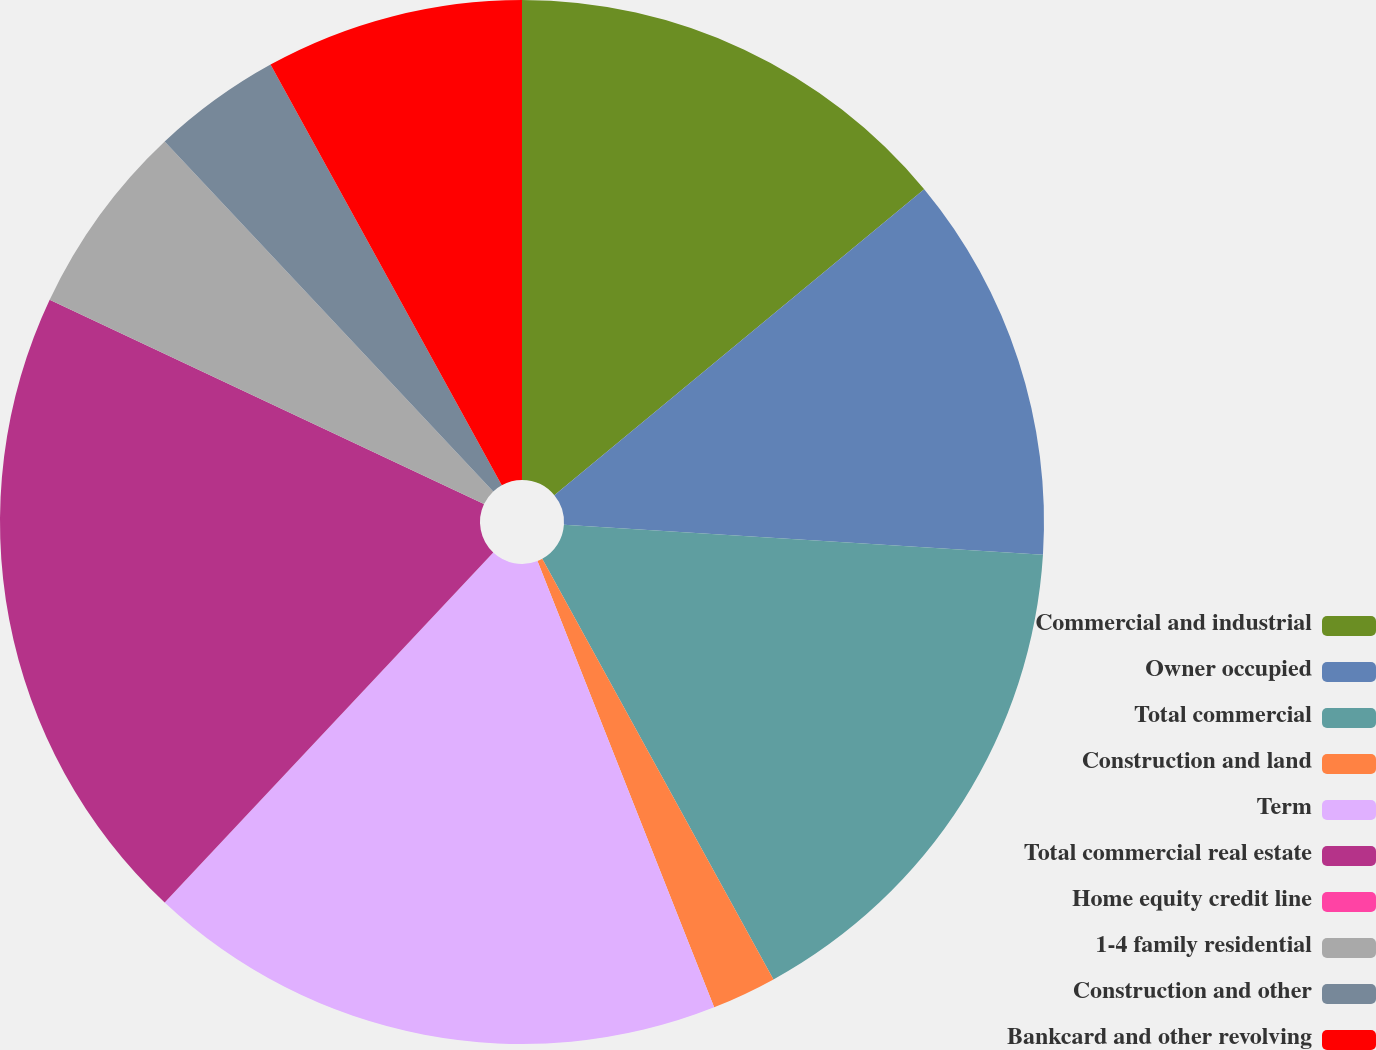<chart> <loc_0><loc_0><loc_500><loc_500><pie_chart><fcel>Commercial and industrial<fcel>Owner occupied<fcel>Total commercial<fcel>Construction and land<fcel>Term<fcel>Total commercial real estate<fcel>Home equity credit line<fcel>1-4 family residential<fcel>Construction and other<fcel>Bankcard and other revolving<nl><fcel>14.0%<fcel>12.0%<fcel>16.0%<fcel>2.0%<fcel>18.0%<fcel>20.0%<fcel>0.0%<fcel>6.0%<fcel>4.0%<fcel>8.0%<nl></chart> 